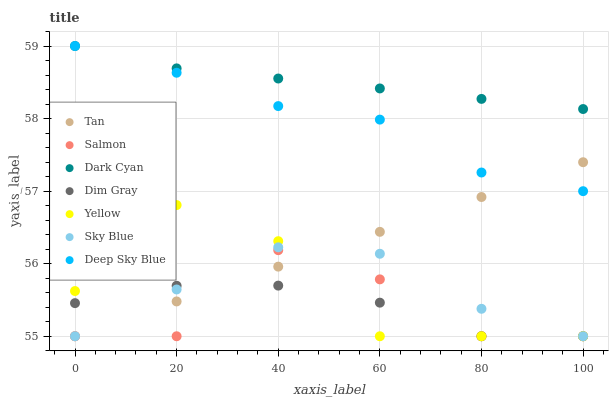Does Salmon have the minimum area under the curve?
Answer yes or no. Yes. Does Dark Cyan have the maximum area under the curve?
Answer yes or no. Yes. Does Yellow have the minimum area under the curve?
Answer yes or no. No. Does Yellow have the maximum area under the curve?
Answer yes or no. No. Is Tan the smoothest?
Answer yes or no. Yes. Is Salmon the roughest?
Answer yes or no. Yes. Is Yellow the smoothest?
Answer yes or no. No. Is Yellow the roughest?
Answer yes or no. No. Does Dim Gray have the lowest value?
Answer yes or no. Yes. Does Deep Sky Blue have the lowest value?
Answer yes or no. No. Does Dark Cyan have the highest value?
Answer yes or no. Yes. Does Salmon have the highest value?
Answer yes or no. No. Is Sky Blue less than Deep Sky Blue?
Answer yes or no. Yes. Is Dark Cyan greater than Sky Blue?
Answer yes or no. Yes. Does Salmon intersect Tan?
Answer yes or no. Yes. Is Salmon less than Tan?
Answer yes or no. No. Is Salmon greater than Tan?
Answer yes or no. No. Does Sky Blue intersect Deep Sky Blue?
Answer yes or no. No. 